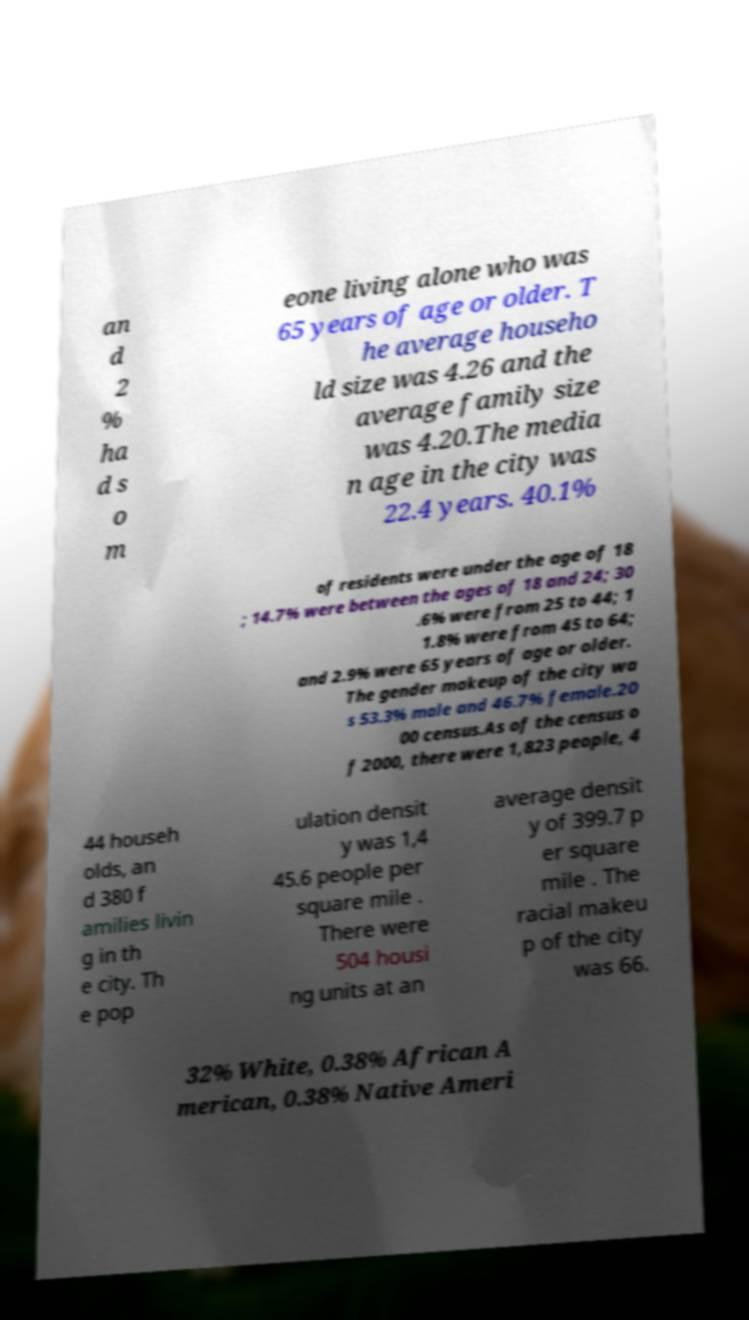Could you extract and type out the text from this image? an d 2 % ha d s o m eone living alone who was 65 years of age or older. T he average househo ld size was 4.26 and the average family size was 4.20.The media n age in the city was 22.4 years. 40.1% of residents were under the age of 18 ; 14.7% were between the ages of 18 and 24; 30 .6% were from 25 to 44; 1 1.8% were from 45 to 64; and 2.9% were 65 years of age or older. The gender makeup of the city wa s 53.3% male and 46.7% female.20 00 census.As of the census o f 2000, there were 1,823 people, 4 44 househ olds, an d 380 f amilies livin g in th e city. Th e pop ulation densit y was 1,4 45.6 people per square mile . There were 504 housi ng units at an average densit y of 399.7 p er square mile . The racial makeu p of the city was 66. 32% White, 0.38% African A merican, 0.38% Native Ameri 